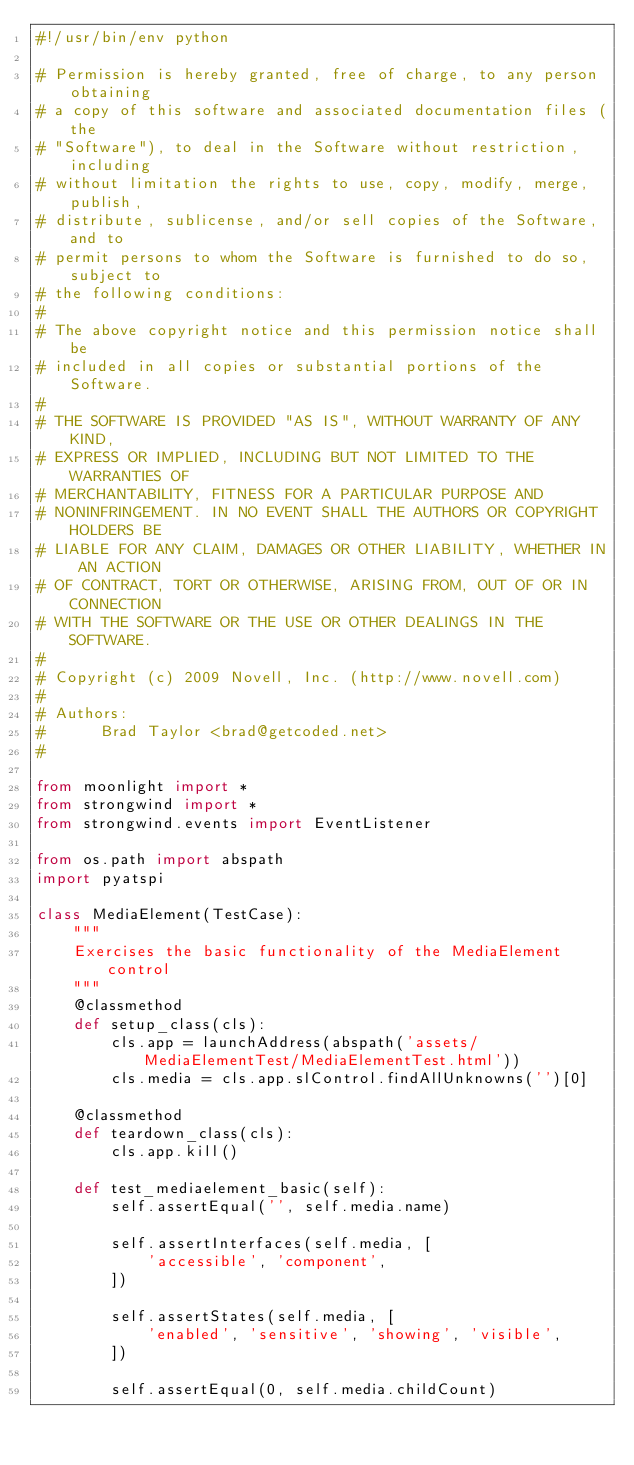Convert code to text. <code><loc_0><loc_0><loc_500><loc_500><_Python_>#!/usr/bin/env python

# Permission is hereby granted, free of charge, to any person obtaining
# a copy of this software and associated documentation files (the
# "Software"), to deal in the Software without restriction, including
# without limitation the rights to use, copy, modify, merge, publish,
# distribute, sublicense, and/or sell copies of the Software, and to
# permit persons to whom the Software is furnished to do so, subject to
# the following conditions:
#
# The above copyright notice and this permission notice shall be
# included in all copies or substantial portions of the Software.
#
# THE SOFTWARE IS PROVIDED "AS IS", WITHOUT WARRANTY OF ANY KIND,
# EXPRESS OR IMPLIED, INCLUDING BUT NOT LIMITED TO THE WARRANTIES OF
# MERCHANTABILITY, FITNESS FOR A PARTICULAR PURPOSE AND
# NONINFRINGEMENT. IN NO EVENT SHALL THE AUTHORS OR COPYRIGHT HOLDERS BE
# LIABLE FOR ANY CLAIM, DAMAGES OR OTHER LIABILITY, WHETHER IN AN ACTION
# OF CONTRACT, TORT OR OTHERWISE, ARISING FROM, OUT OF OR IN CONNECTION
# WITH THE SOFTWARE OR THE USE OR OTHER DEALINGS IN THE SOFTWARE.
#
# Copyright (c) 2009 Novell, Inc. (http://www.novell.com)
#
# Authors:
#      Brad Taylor <brad@getcoded.net>
#

from moonlight import *
from strongwind import *
from strongwind.events import EventListener

from os.path import abspath
import pyatspi

class MediaElement(TestCase):
    """
    Exercises the basic functionality of the MediaElement control
    """
    @classmethod
    def setup_class(cls):
        cls.app = launchAddress(abspath('assets/MediaElementTest/MediaElementTest.html'))
        cls.media = cls.app.slControl.findAllUnknowns('')[0]

    @classmethod
    def teardown_class(cls):
        cls.app.kill()

    def test_mediaelement_basic(self):
        self.assertEqual('', self.media.name)

        self.assertInterfaces(self.media, [
            'accessible', 'component',
        ])

        self.assertStates(self.media, [
            'enabled', 'sensitive', 'showing', 'visible',
        ])

        self.assertEqual(0, self.media.childCount)
</code> 